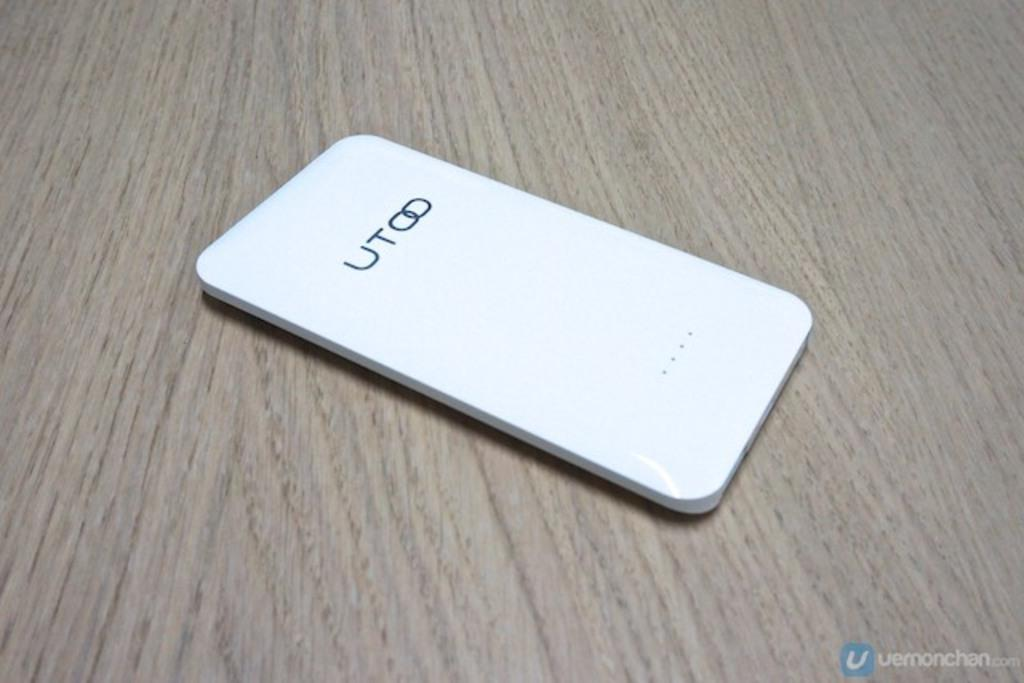<image>
Share a concise interpretation of the image provided. UT white cell phone on itself on the table. 